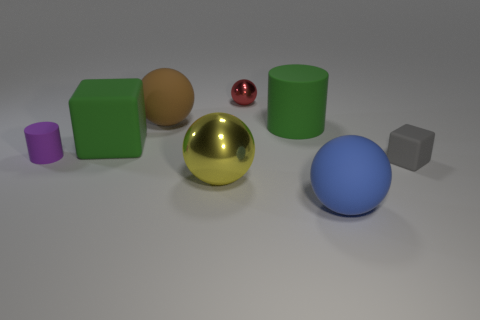There is a big object that is the same color as the large rubber block; what is its shape?
Ensure brevity in your answer.  Cylinder. Is there a large brown object behind the rubber ball that is behind the green rubber cube?
Offer a terse response. No. How many other small red balls have the same material as the small ball?
Your response must be concise. 0. There is a rubber block behind the small matte thing that is left of the big metallic ball to the left of the red thing; how big is it?
Your answer should be very brief. Large. There is a tiny purple rubber object; what number of small red balls are left of it?
Offer a very short reply. 0. Is the number of big red spheres greater than the number of gray rubber blocks?
Your answer should be compact. No. The cube that is the same color as the big cylinder is what size?
Make the answer very short. Large. There is a matte thing that is both behind the large green block and in front of the large brown object; what is its size?
Your response must be concise. Large. What material is the ball that is on the right side of the big matte cylinder that is behind the matte thing right of the blue sphere made of?
Ensure brevity in your answer.  Rubber. There is a thing that is the same color as the large cube; what is it made of?
Ensure brevity in your answer.  Rubber. 